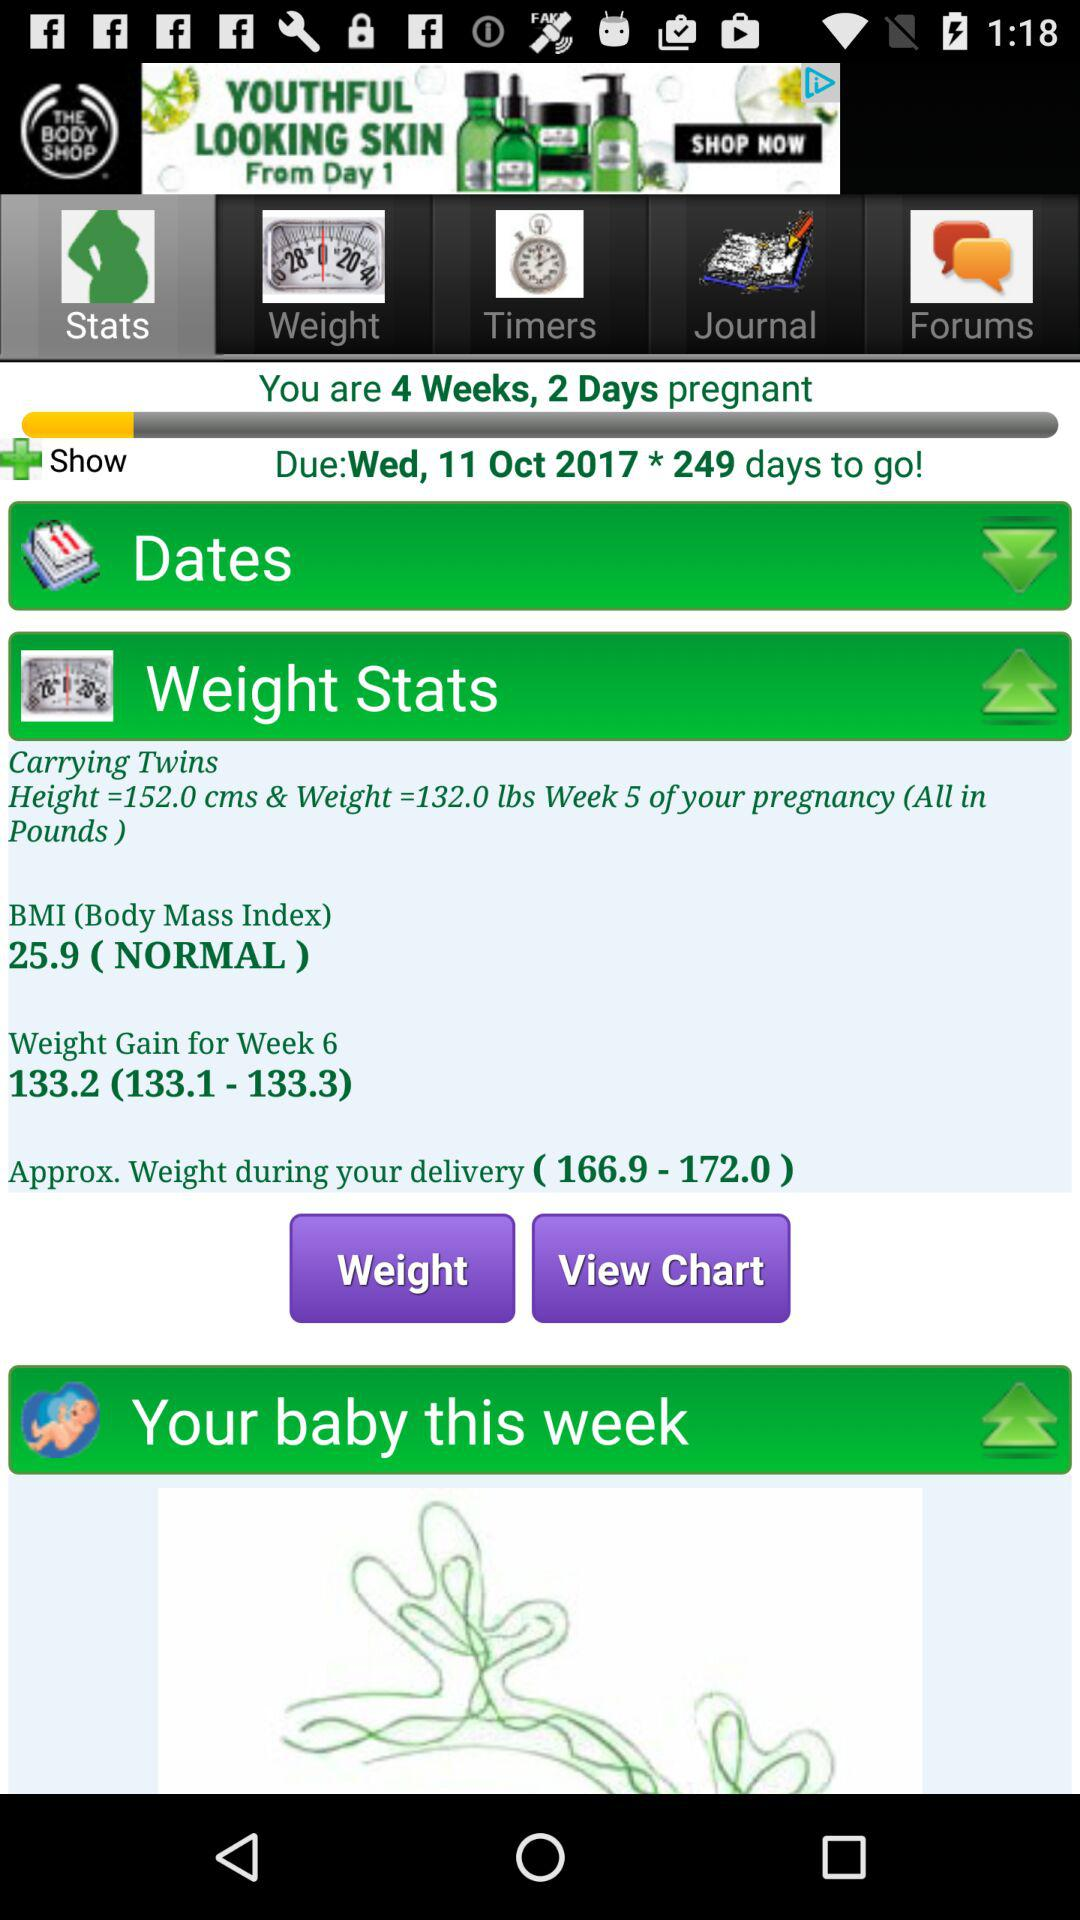Which tab has been selected? The selected tab is "Stats". 